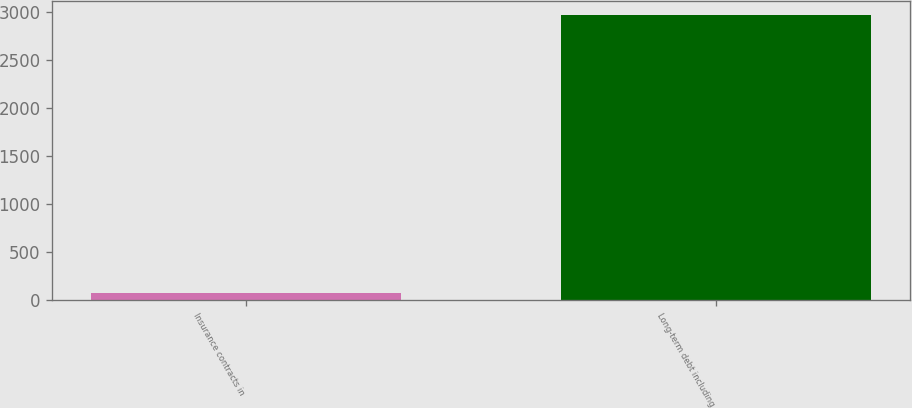Convert chart to OTSL. <chart><loc_0><loc_0><loc_500><loc_500><bar_chart><fcel>Insurance contracts in<fcel>Long-term debt including<nl><fcel>69<fcel>2967<nl></chart> 